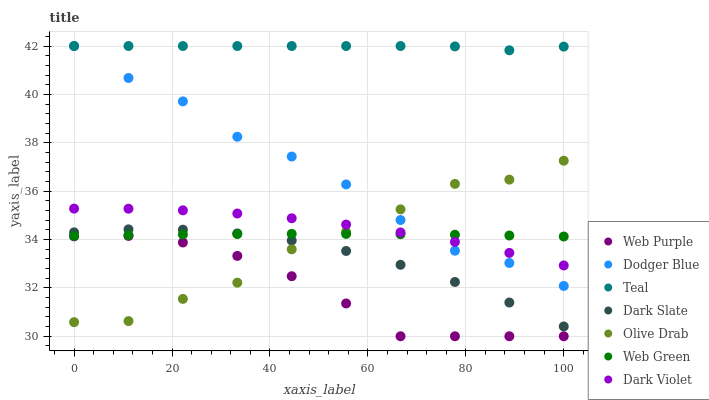Does Web Purple have the minimum area under the curve?
Answer yes or no. Yes. Does Teal have the maximum area under the curve?
Answer yes or no. Yes. Does Dark Slate have the minimum area under the curve?
Answer yes or no. No. Does Dark Slate have the maximum area under the curve?
Answer yes or no. No. Is Web Green the smoothest?
Answer yes or no. Yes. Is Olive Drab the roughest?
Answer yes or no. Yes. Is Dark Slate the smoothest?
Answer yes or no. No. Is Dark Slate the roughest?
Answer yes or no. No. Does Web Purple have the lowest value?
Answer yes or no. Yes. Does Dark Slate have the lowest value?
Answer yes or no. No. Does Teal have the highest value?
Answer yes or no. Yes. Does Dark Slate have the highest value?
Answer yes or no. No. Is Olive Drab less than Teal?
Answer yes or no. Yes. Is Dark Violet greater than Web Purple?
Answer yes or no. Yes. Does Olive Drab intersect Web Purple?
Answer yes or no. Yes. Is Olive Drab less than Web Purple?
Answer yes or no. No. Is Olive Drab greater than Web Purple?
Answer yes or no. No. Does Olive Drab intersect Teal?
Answer yes or no. No. 